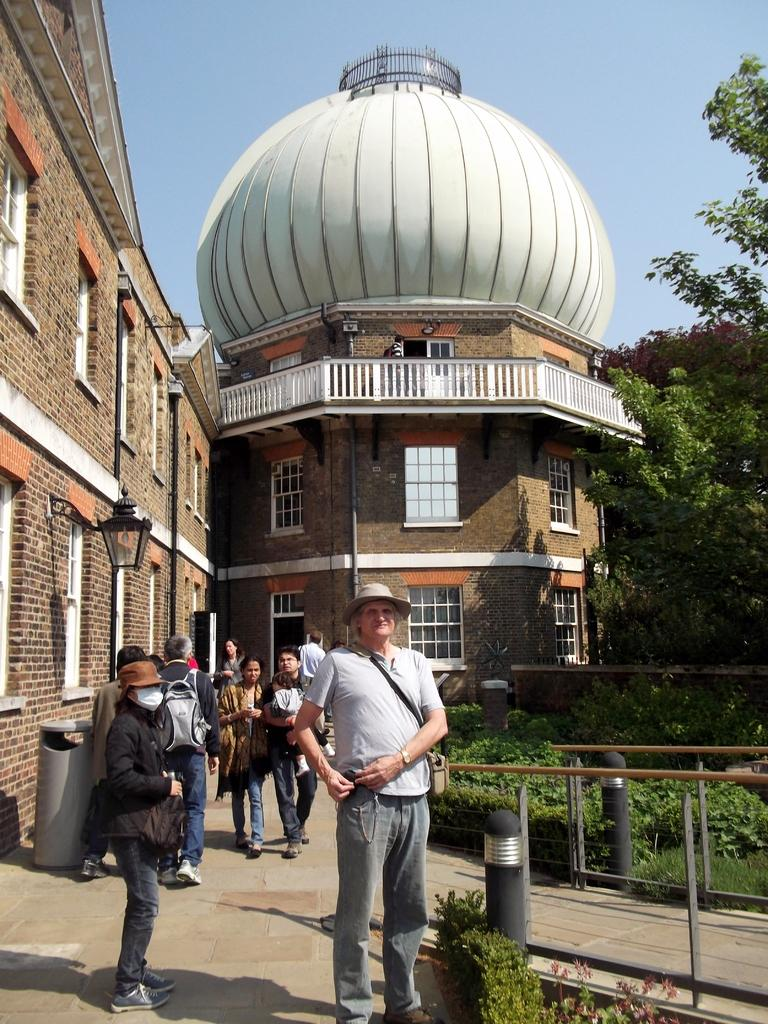What type of structures are visible in the image? There are buildings with windows in the image. What other natural elements can be seen in the image? There are trees in the image. What are the people in the image doing? People are walking in the image. What is visible in the background of the image? The sky is visible in the image. Can you tell me how many maids are stitching in the image? There are no maids or stitching activities present in the image. What type of act is being performed by the people in the image? There is no act being performed by the people in the image; they are simply walking. 